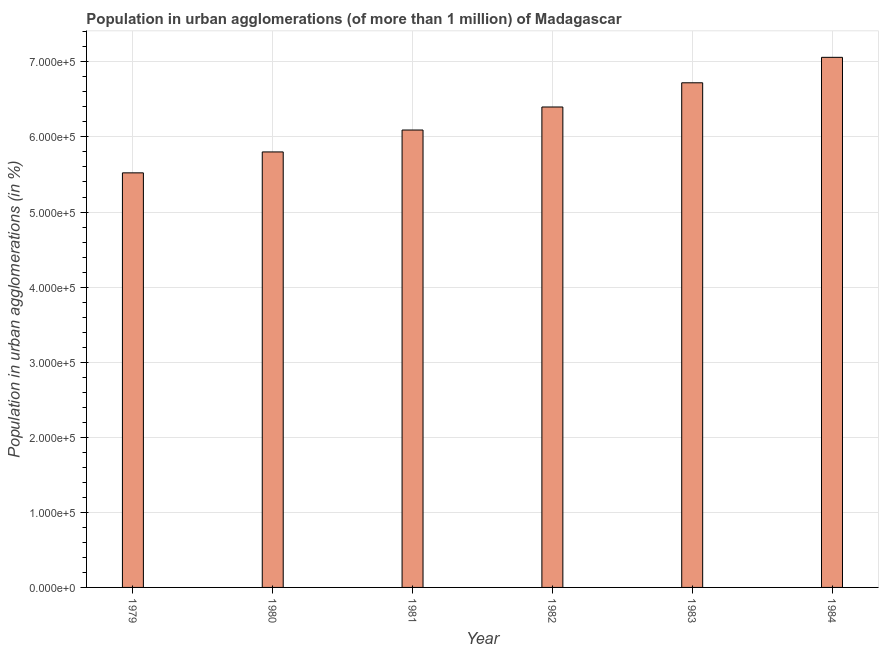Does the graph contain any zero values?
Offer a terse response. No. What is the title of the graph?
Offer a terse response. Population in urban agglomerations (of more than 1 million) of Madagascar. What is the label or title of the X-axis?
Offer a terse response. Year. What is the label or title of the Y-axis?
Keep it short and to the point. Population in urban agglomerations (in %). What is the population in urban agglomerations in 1979?
Make the answer very short. 5.52e+05. Across all years, what is the maximum population in urban agglomerations?
Your answer should be very brief. 7.06e+05. Across all years, what is the minimum population in urban agglomerations?
Offer a terse response. 5.52e+05. In which year was the population in urban agglomerations minimum?
Make the answer very short. 1979. What is the sum of the population in urban agglomerations?
Your answer should be compact. 3.76e+06. What is the difference between the population in urban agglomerations in 1979 and 1982?
Make the answer very short. -8.77e+04. What is the average population in urban agglomerations per year?
Make the answer very short. 6.27e+05. What is the median population in urban agglomerations?
Offer a very short reply. 6.25e+05. In how many years, is the population in urban agglomerations greater than 400000 %?
Your answer should be very brief. 6. What is the difference between the highest and the second highest population in urban agglomerations?
Make the answer very short. 3.39e+04. Is the sum of the population in urban agglomerations in 1982 and 1984 greater than the maximum population in urban agglomerations across all years?
Provide a short and direct response. Yes. What is the difference between the highest and the lowest population in urban agglomerations?
Keep it short and to the point. 1.54e+05. How many bars are there?
Your response must be concise. 6. Are all the bars in the graph horizontal?
Give a very brief answer. No. How many years are there in the graph?
Your answer should be compact. 6. What is the difference between two consecutive major ticks on the Y-axis?
Offer a very short reply. 1.00e+05. What is the Population in urban agglomerations (in %) in 1979?
Your response must be concise. 5.52e+05. What is the Population in urban agglomerations (in %) of 1980?
Provide a succinct answer. 5.80e+05. What is the Population in urban agglomerations (in %) in 1981?
Your response must be concise. 6.09e+05. What is the Population in urban agglomerations (in %) in 1982?
Keep it short and to the point. 6.40e+05. What is the Population in urban agglomerations (in %) in 1983?
Offer a terse response. 6.72e+05. What is the Population in urban agglomerations (in %) of 1984?
Offer a very short reply. 7.06e+05. What is the difference between the Population in urban agglomerations (in %) in 1979 and 1980?
Keep it short and to the point. -2.79e+04. What is the difference between the Population in urban agglomerations (in %) in 1979 and 1981?
Give a very brief answer. -5.70e+04. What is the difference between the Population in urban agglomerations (in %) in 1979 and 1982?
Make the answer very short. -8.77e+04. What is the difference between the Population in urban agglomerations (in %) in 1979 and 1983?
Ensure brevity in your answer.  -1.20e+05. What is the difference between the Population in urban agglomerations (in %) in 1979 and 1984?
Keep it short and to the point. -1.54e+05. What is the difference between the Population in urban agglomerations (in %) in 1980 and 1981?
Make the answer very short. -2.92e+04. What is the difference between the Population in urban agglomerations (in %) in 1980 and 1982?
Your answer should be very brief. -5.99e+04. What is the difference between the Population in urban agglomerations (in %) in 1980 and 1983?
Your answer should be very brief. -9.21e+04. What is the difference between the Population in urban agglomerations (in %) in 1980 and 1984?
Your response must be concise. -1.26e+05. What is the difference between the Population in urban agglomerations (in %) in 1981 and 1982?
Offer a very short reply. -3.07e+04. What is the difference between the Population in urban agglomerations (in %) in 1981 and 1983?
Your answer should be very brief. -6.29e+04. What is the difference between the Population in urban agglomerations (in %) in 1981 and 1984?
Your response must be concise. -9.68e+04. What is the difference between the Population in urban agglomerations (in %) in 1982 and 1983?
Offer a terse response. -3.22e+04. What is the difference between the Population in urban agglomerations (in %) in 1982 and 1984?
Offer a terse response. -6.61e+04. What is the difference between the Population in urban agglomerations (in %) in 1983 and 1984?
Offer a very short reply. -3.39e+04. What is the ratio of the Population in urban agglomerations (in %) in 1979 to that in 1981?
Make the answer very short. 0.91. What is the ratio of the Population in urban agglomerations (in %) in 1979 to that in 1982?
Make the answer very short. 0.86. What is the ratio of the Population in urban agglomerations (in %) in 1979 to that in 1983?
Your answer should be compact. 0.82. What is the ratio of the Population in urban agglomerations (in %) in 1979 to that in 1984?
Give a very brief answer. 0.78. What is the ratio of the Population in urban agglomerations (in %) in 1980 to that in 1982?
Your answer should be very brief. 0.91. What is the ratio of the Population in urban agglomerations (in %) in 1980 to that in 1983?
Give a very brief answer. 0.86. What is the ratio of the Population in urban agglomerations (in %) in 1980 to that in 1984?
Make the answer very short. 0.82. What is the ratio of the Population in urban agglomerations (in %) in 1981 to that in 1983?
Your response must be concise. 0.91. What is the ratio of the Population in urban agglomerations (in %) in 1981 to that in 1984?
Your response must be concise. 0.86. What is the ratio of the Population in urban agglomerations (in %) in 1982 to that in 1984?
Give a very brief answer. 0.91. 